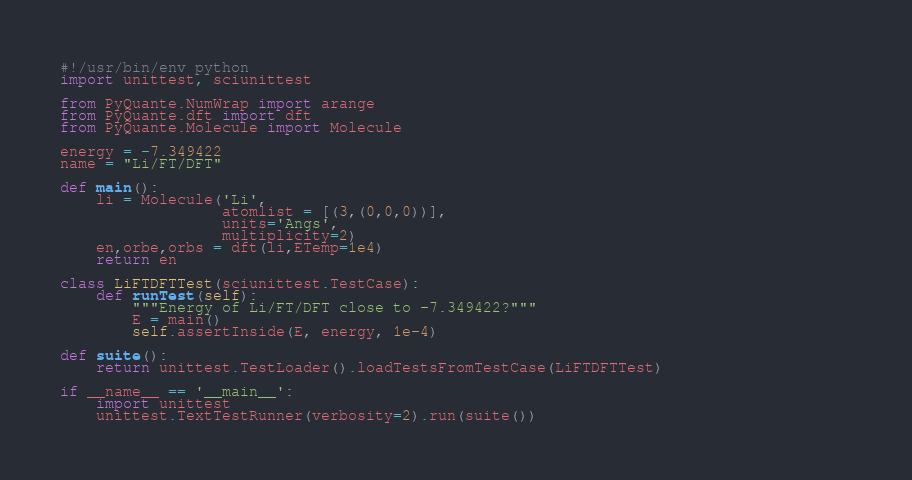Convert code to text. <code><loc_0><loc_0><loc_500><loc_500><_Python_>#!/usr/bin/env python
import unittest, sciunittest

from PyQuante.NumWrap import arange
from PyQuante.dft import dft
from PyQuante.Molecule import Molecule

energy = -7.349422
name = "Li/FT/DFT"

def main():
    li = Molecule('Li',
                  atomlist = [(3,(0,0,0))],
                  units='Angs',
                  multiplicity=2)
    en,orbe,orbs = dft(li,ETemp=1e4)
    return en

class LiFTDFTTest(sciunittest.TestCase):
    def runTest(self):
        """Energy of Li/FT/DFT close to -7.349422?"""
        E = main()
        self.assertInside(E, energy, 1e-4)

def suite():
    return unittest.TestLoader().loadTestsFromTestCase(LiFTDFTTest)

if __name__ == '__main__':
    import unittest
    unittest.TextTestRunner(verbosity=2).run(suite())                                   
</code> 